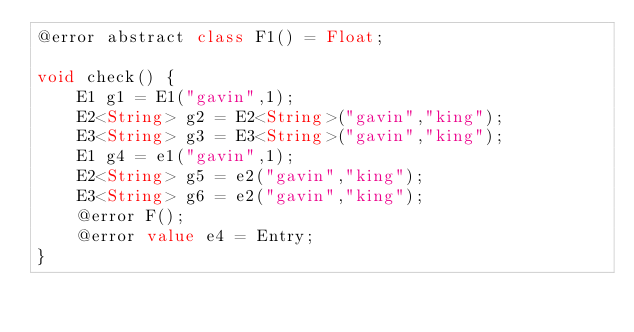<code> <loc_0><loc_0><loc_500><loc_500><_Ceylon_>@error abstract class F1() = Float;

void check() { 
    E1 g1 = E1("gavin",1); 
    E2<String> g2 = E2<String>("gavin","king"); 
    E3<String> g3 = E3<String>("gavin","king"); 
    E1 g4 = e1("gavin",1); 
    E2<String> g5 = e2("gavin","king"); 
    E3<String> g6 = e2("gavin","king"); 
    @error F();
    @error value e4 = Entry;
}</code> 